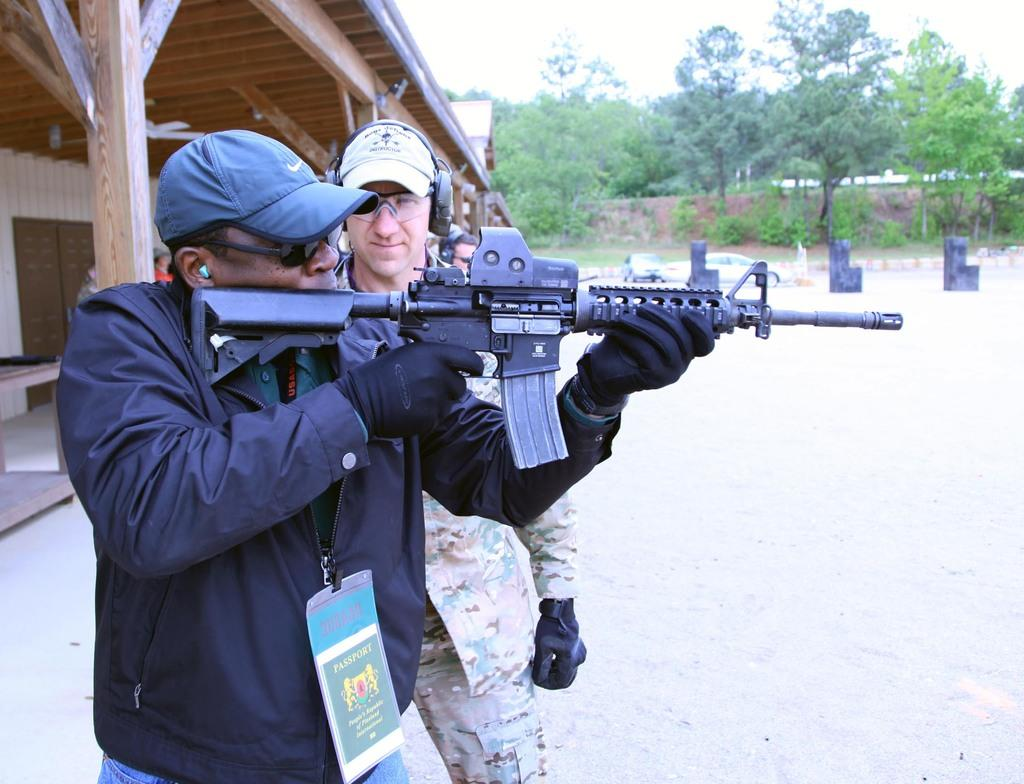How many people are in the image? There are two persons standing in the center of the image. What can be seen in the background of the image? There are trees in the background of the image. Where is the house located in the image? The house is to the left side of the image. What type of salt is being used by the persons in the image? There is no salt present in the image, and the persons are not using any salt. Can you see a cat in the image? There is no cat present in the image. 